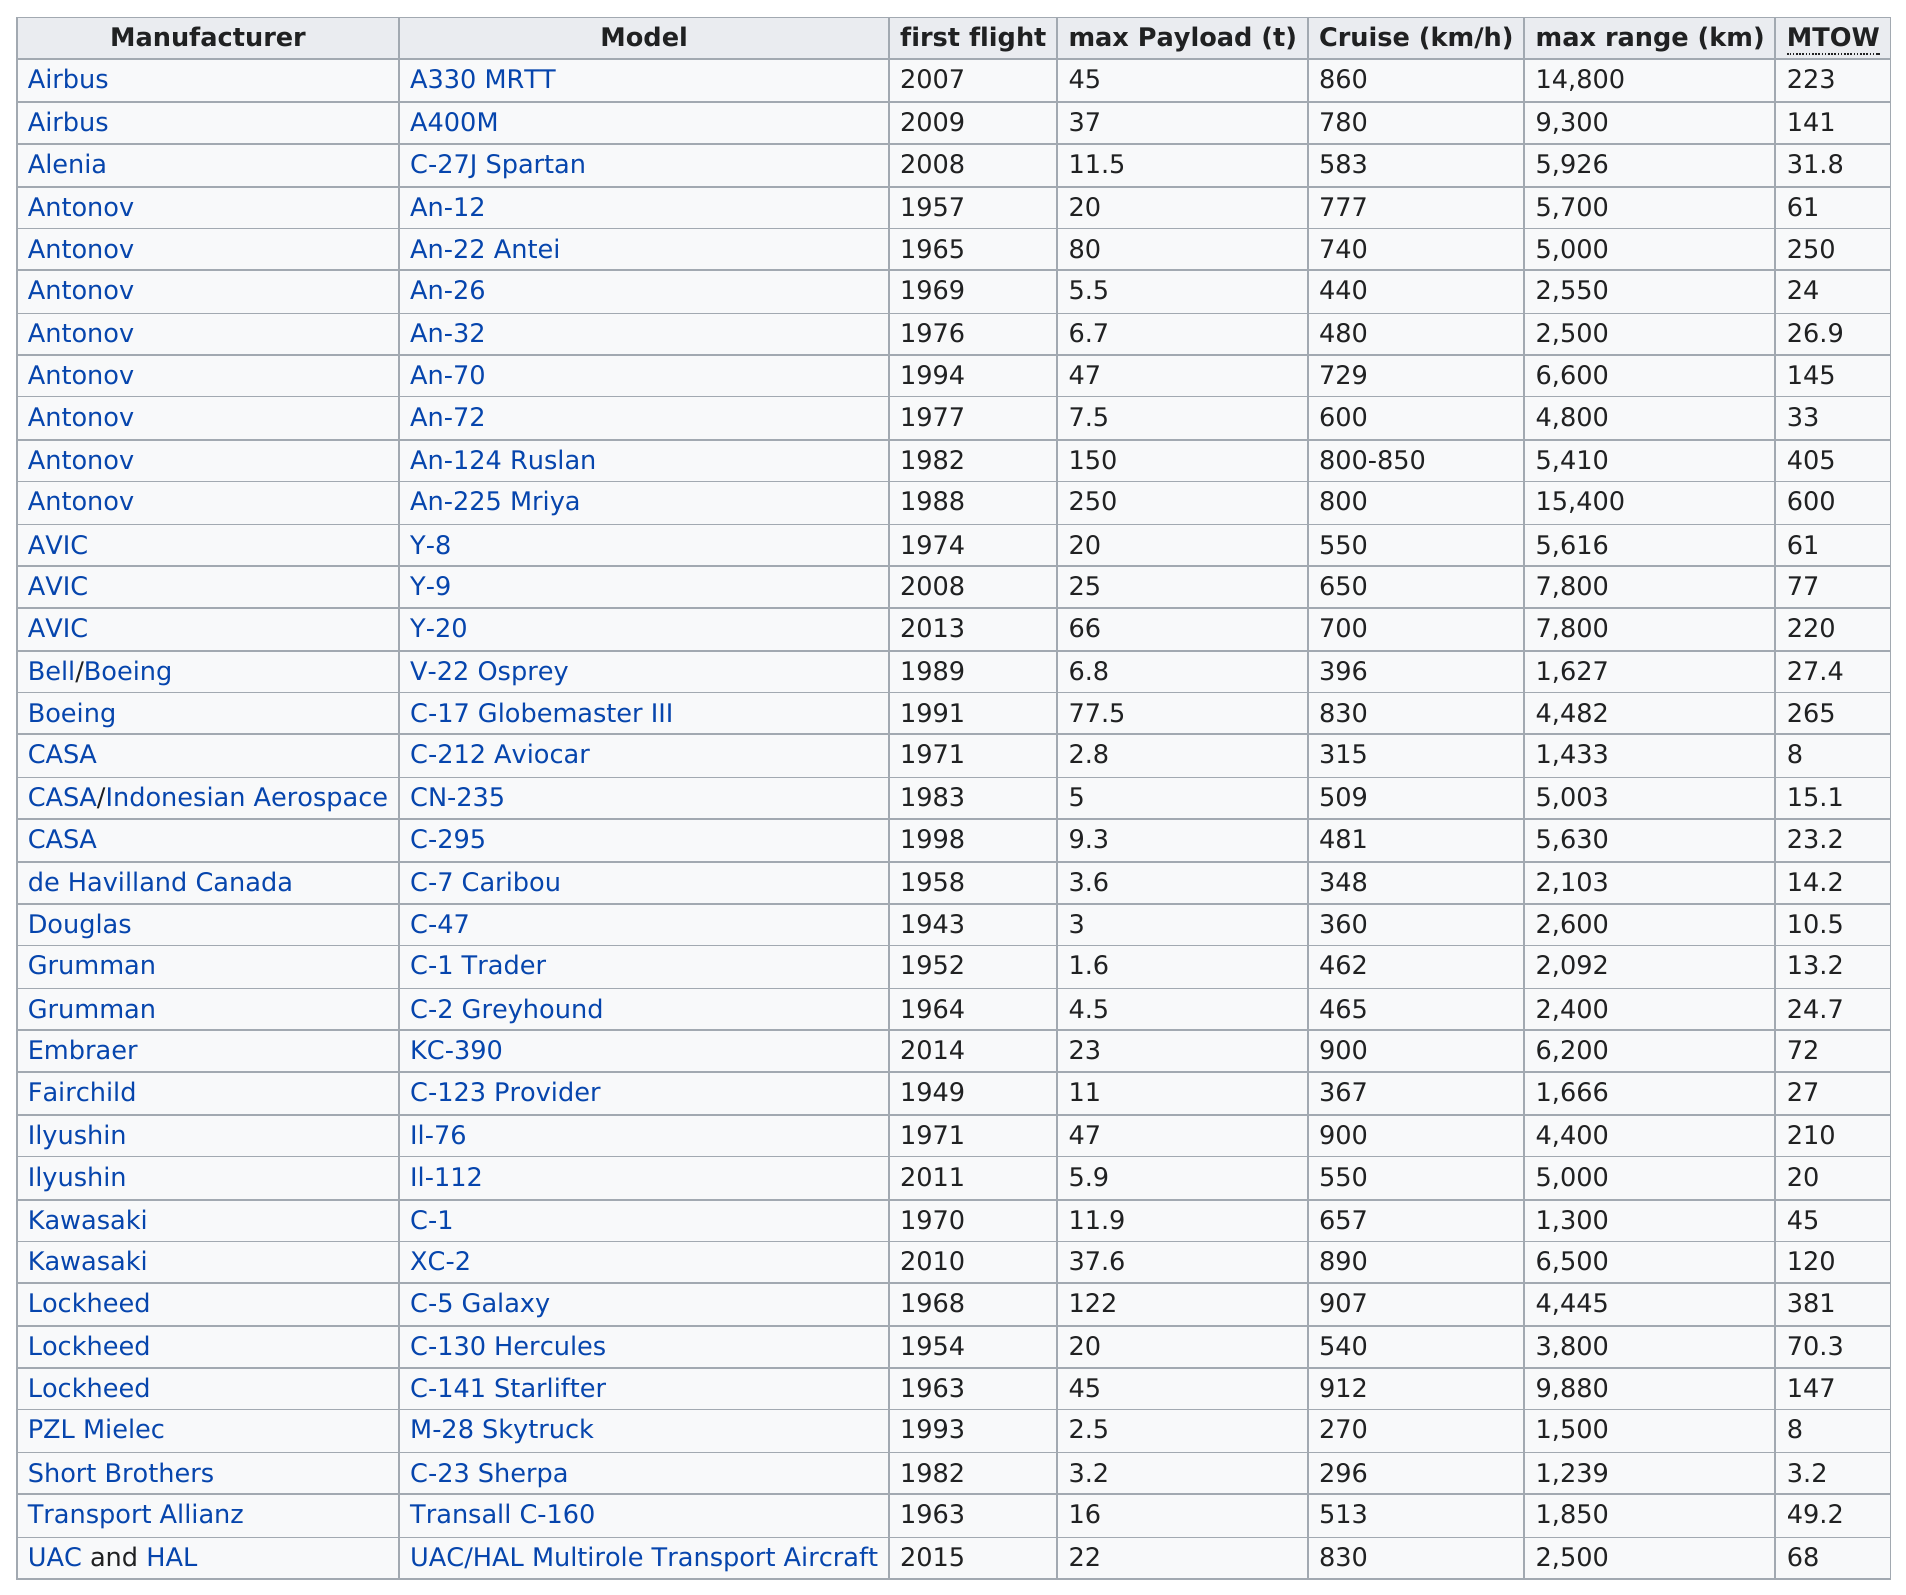Identify some key points in this picture. The maximum range was 4,000 or more 21 times. The UAC/HAL Multirole Transport Aircraft is the name of the last model listed on this chart. Antonov is listed as the manufacturer 8 times in the list provided. The first model of the aircraft had its first flight in 2007. The maximum range of the C-5 Galaxy is greater than that of the C-1 Trader. 